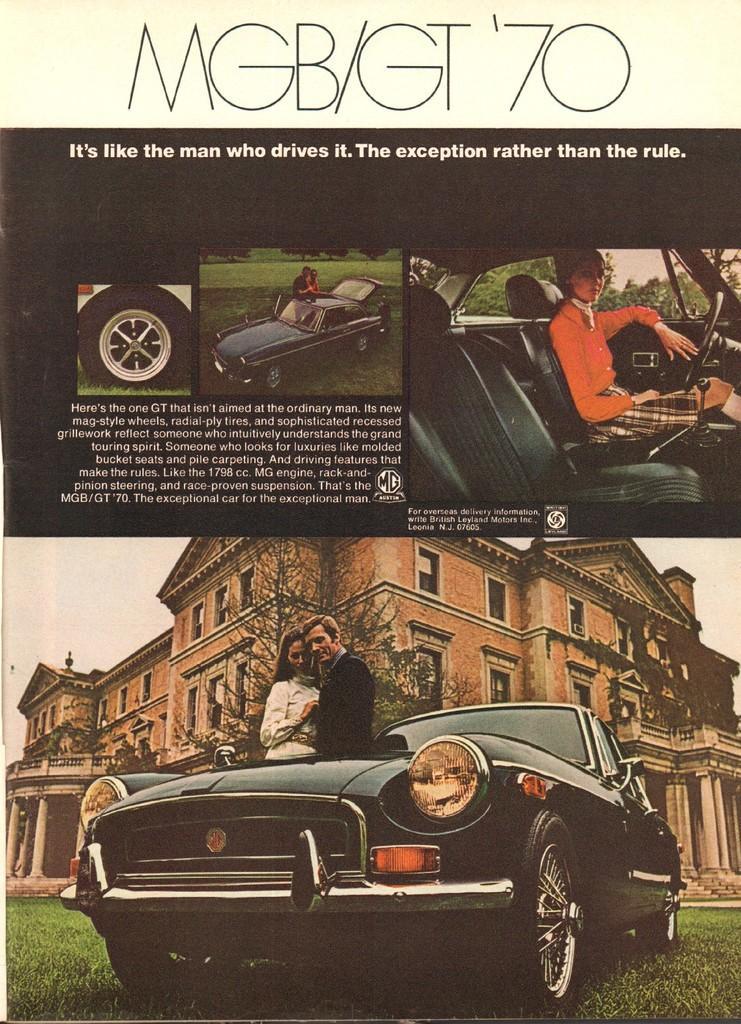Describe this image in one or two sentences. In this image I can see a pamphlet, in the pamphlet I can see a vehicle, two persons standing, building in brown color. I can also see a person sitting in the car. 